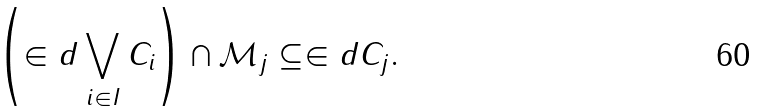<formula> <loc_0><loc_0><loc_500><loc_500>\left ( \in d \bigvee _ { i \in I } C _ { i } \right ) \cap \mathcal { M } _ { j } \subseteq \in d C _ { j } .</formula> 